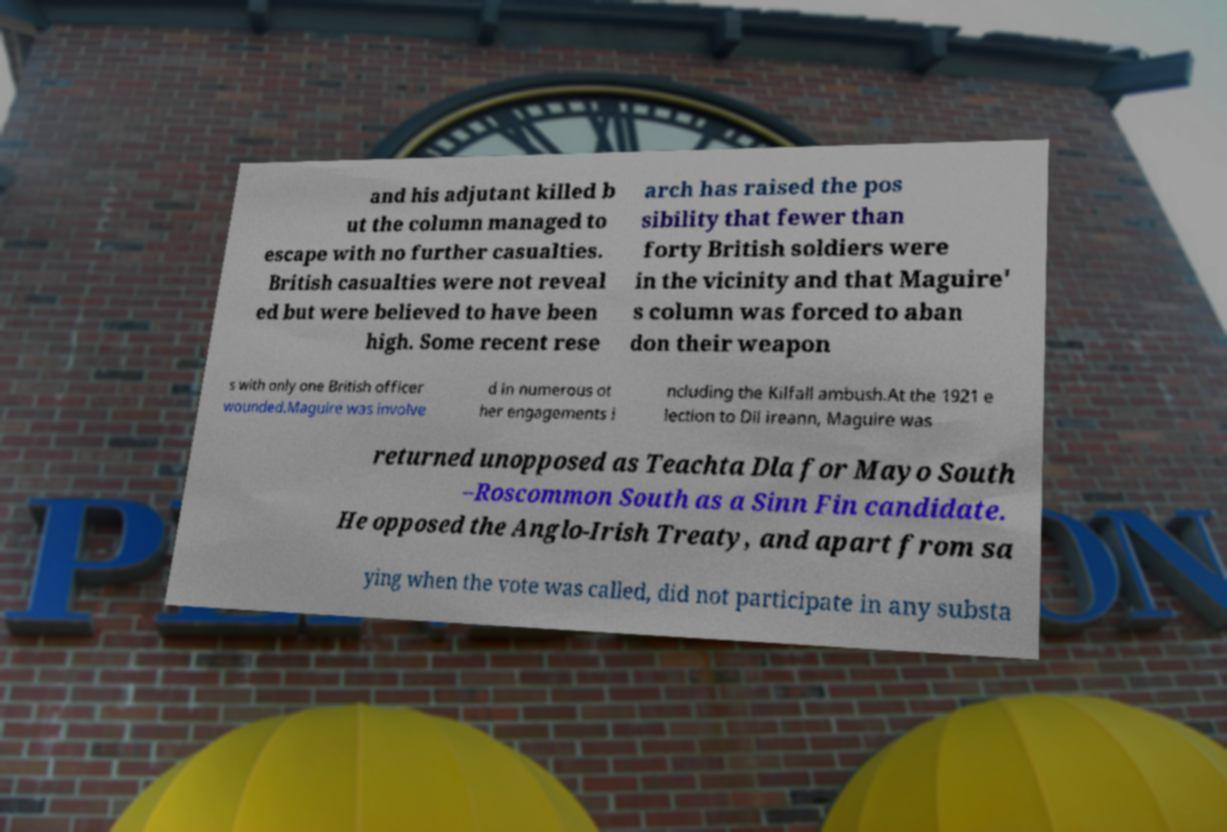There's text embedded in this image that I need extracted. Can you transcribe it verbatim? and his adjutant killed b ut the column managed to escape with no further casualties. British casualties were not reveal ed but were believed to have been high. Some recent rese arch has raised the pos sibility that fewer than forty British soldiers were in the vicinity and that Maguire' s column was forced to aban don their weapon s with only one British officer wounded.Maguire was involve d in numerous ot her engagements i ncluding the Kilfall ambush.At the 1921 e lection to Dil ireann, Maguire was returned unopposed as Teachta Dla for Mayo South –Roscommon South as a Sinn Fin candidate. He opposed the Anglo-Irish Treaty, and apart from sa ying when the vote was called, did not participate in any substa 